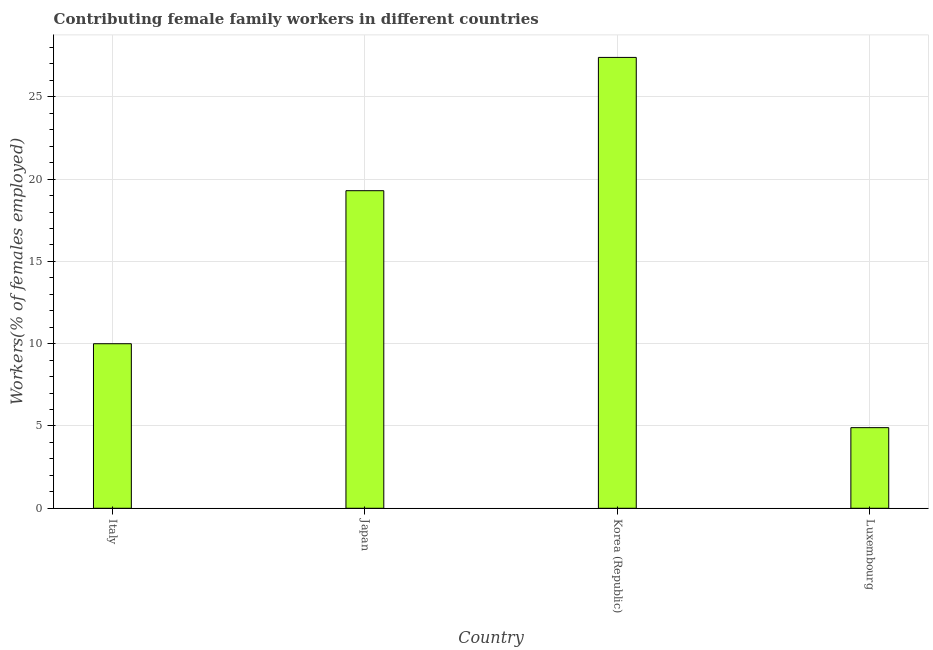Does the graph contain any zero values?
Keep it short and to the point. No. What is the title of the graph?
Give a very brief answer. Contributing female family workers in different countries. What is the label or title of the X-axis?
Give a very brief answer. Country. What is the label or title of the Y-axis?
Offer a very short reply. Workers(% of females employed). What is the contributing female family workers in Italy?
Keep it short and to the point. 10. Across all countries, what is the maximum contributing female family workers?
Keep it short and to the point. 27.4. Across all countries, what is the minimum contributing female family workers?
Make the answer very short. 4.9. In which country was the contributing female family workers minimum?
Offer a terse response. Luxembourg. What is the sum of the contributing female family workers?
Your answer should be compact. 61.6. What is the average contributing female family workers per country?
Offer a very short reply. 15.4. What is the median contributing female family workers?
Provide a succinct answer. 14.65. What is the ratio of the contributing female family workers in Japan to that in Korea (Republic)?
Provide a short and direct response. 0.7. What is the difference between the highest and the second highest contributing female family workers?
Offer a terse response. 8.1. Is the sum of the contributing female family workers in Italy and Japan greater than the maximum contributing female family workers across all countries?
Your answer should be compact. Yes. Are all the bars in the graph horizontal?
Your answer should be compact. No. How many countries are there in the graph?
Give a very brief answer. 4. What is the difference between two consecutive major ticks on the Y-axis?
Provide a short and direct response. 5. Are the values on the major ticks of Y-axis written in scientific E-notation?
Keep it short and to the point. No. What is the Workers(% of females employed) of Italy?
Your answer should be compact. 10. What is the Workers(% of females employed) in Japan?
Your answer should be compact. 19.3. What is the Workers(% of females employed) of Korea (Republic)?
Make the answer very short. 27.4. What is the Workers(% of females employed) in Luxembourg?
Provide a short and direct response. 4.9. What is the difference between the Workers(% of females employed) in Italy and Korea (Republic)?
Make the answer very short. -17.4. What is the difference between the Workers(% of females employed) in Japan and Korea (Republic)?
Give a very brief answer. -8.1. What is the difference between the Workers(% of females employed) in Korea (Republic) and Luxembourg?
Offer a terse response. 22.5. What is the ratio of the Workers(% of females employed) in Italy to that in Japan?
Make the answer very short. 0.52. What is the ratio of the Workers(% of females employed) in Italy to that in Korea (Republic)?
Your answer should be compact. 0.36. What is the ratio of the Workers(% of females employed) in Italy to that in Luxembourg?
Keep it short and to the point. 2.04. What is the ratio of the Workers(% of females employed) in Japan to that in Korea (Republic)?
Your answer should be very brief. 0.7. What is the ratio of the Workers(% of females employed) in Japan to that in Luxembourg?
Your answer should be very brief. 3.94. What is the ratio of the Workers(% of females employed) in Korea (Republic) to that in Luxembourg?
Make the answer very short. 5.59. 